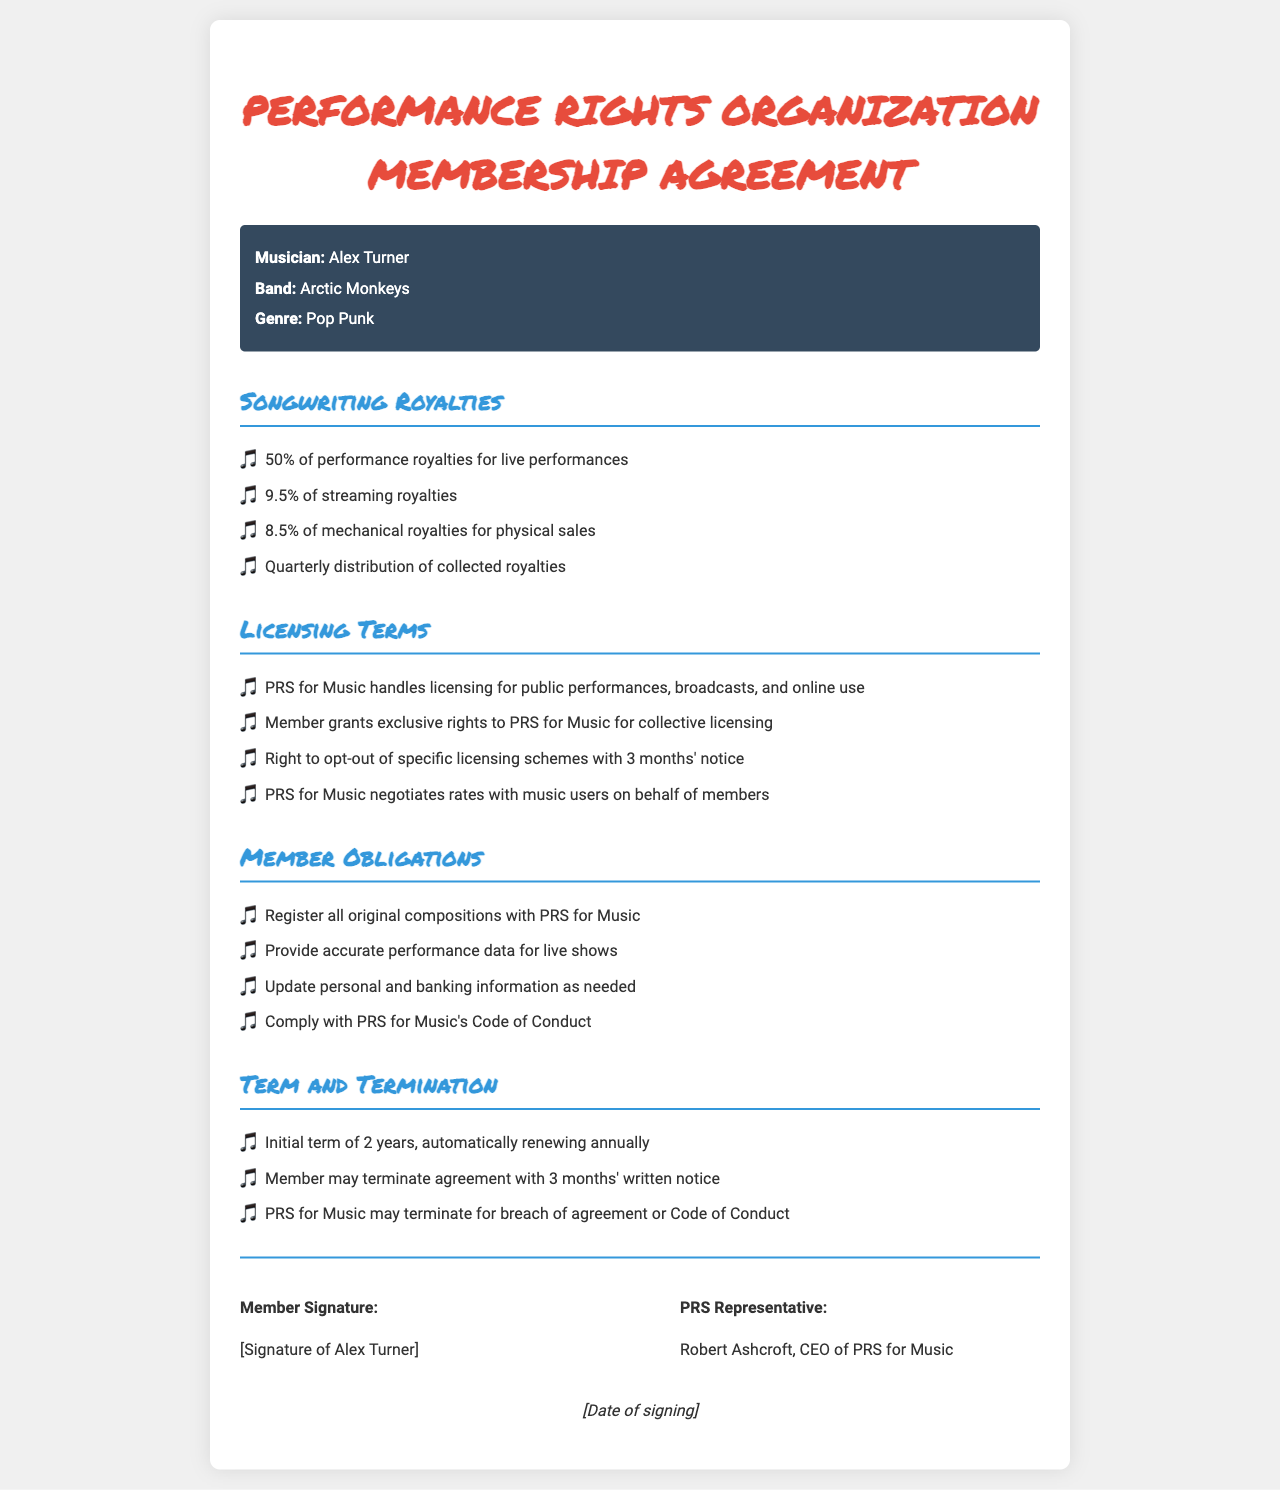What is the musician's name? The musician's name is listed at the top of the document under musician details.
Answer: Alex Turner What percentage of performance royalties do members receive for live performances? The percentage for live performance royalties is specified under songwriting royalties.
Answer: 50% Which organization handles licensing for public performances? The licensing organization is mentioned in the licensing terms section of the document.
Answer: PRS for Music How often are royalties distributed to members? The frequency of royalty distribution is mentioned in the songwriting royalties section.
Answer: Quarterly What is the initial term of the agreement? The length of the initial term is stated under the term and termination section.
Answer: 2 years What type of royalties do members receive for streaming? The document specifies the royalty type and percentage in the songwriting royalties section.
Answer: 9.5% What obligation does a member have regarding original compositions? The obligation related to original compositions is described in the member obligations section.
Answer: Register all original compositions with PRS for Music How much notice is required to opt-out of specific licensing schemes? The notice period for opting out is specified in the licensing terms section.
Answer: 3 months Who is the CEO of PRS for Music? The CEO's name is listed in the signature block of the document.
Answer: Robert Ashcroft 